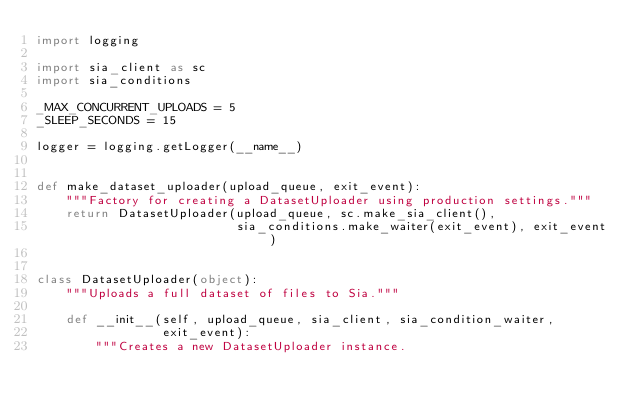Convert code to text. <code><loc_0><loc_0><loc_500><loc_500><_Python_>import logging

import sia_client as sc
import sia_conditions

_MAX_CONCURRENT_UPLOADS = 5
_SLEEP_SECONDS = 15

logger = logging.getLogger(__name__)


def make_dataset_uploader(upload_queue, exit_event):
    """Factory for creating a DatasetUploader using production settings."""
    return DatasetUploader(upload_queue, sc.make_sia_client(),
                           sia_conditions.make_waiter(exit_event), exit_event)


class DatasetUploader(object):
    """Uploads a full dataset of files to Sia."""

    def __init__(self, upload_queue, sia_client, sia_condition_waiter,
                 exit_event):
        """Creates a new DatasetUploader instance.
</code> 